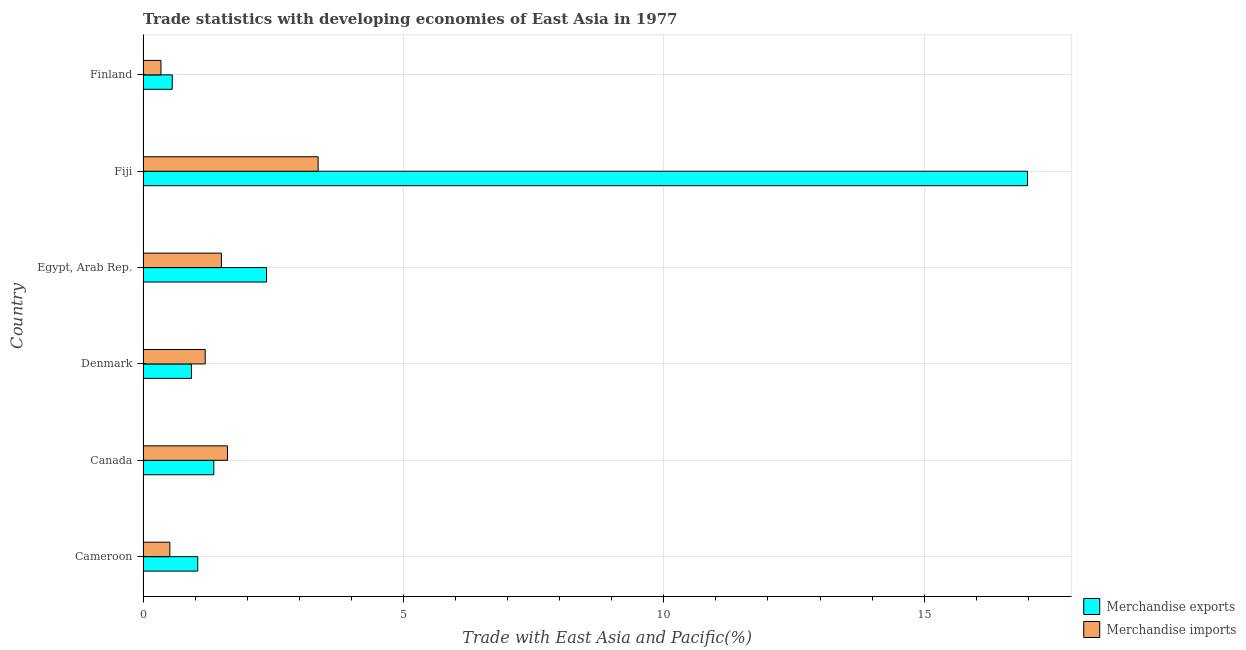Are the number of bars on each tick of the Y-axis equal?
Offer a very short reply. Yes. How many bars are there on the 6th tick from the top?
Your answer should be very brief. 2. How many bars are there on the 5th tick from the bottom?
Give a very brief answer. 2. What is the label of the 6th group of bars from the top?
Your answer should be compact. Cameroon. What is the merchandise imports in Finland?
Offer a terse response. 0.34. Across all countries, what is the maximum merchandise exports?
Your answer should be compact. 16.98. Across all countries, what is the minimum merchandise imports?
Offer a terse response. 0.34. In which country was the merchandise exports maximum?
Your response must be concise. Fiji. In which country was the merchandise imports minimum?
Provide a short and direct response. Finland. What is the total merchandise exports in the graph?
Give a very brief answer. 23.25. What is the difference between the merchandise exports in Canada and that in Denmark?
Your answer should be very brief. 0.43. What is the difference between the merchandise imports in Finland and the merchandise exports in Egypt, Arab Rep.?
Keep it short and to the point. -2.03. What is the average merchandise imports per country?
Give a very brief answer. 1.42. What is the difference between the merchandise exports and merchandise imports in Canada?
Make the answer very short. -0.26. In how many countries, is the merchandise imports greater than 15 %?
Offer a terse response. 0. What is the ratio of the merchandise imports in Canada to that in Denmark?
Your answer should be very brief. 1.36. Is the merchandise imports in Denmark less than that in Egypt, Arab Rep.?
Make the answer very short. Yes. Is the difference between the merchandise exports in Cameroon and Denmark greater than the difference between the merchandise imports in Cameroon and Denmark?
Provide a succinct answer. Yes. What is the difference between the highest and the second highest merchandise imports?
Your answer should be very brief. 1.74. What is the difference between the highest and the lowest merchandise exports?
Make the answer very short. 16.42. What does the 1st bar from the bottom in Fiji represents?
Provide a short and direct response. Merchandise exports. Are all the bars in the graph horizontal?
Your response must be concise. Yes. How many countries are there in the graph?
Your answer should be compact. 6. Are the values on the major ticks of X-axis written in scientific E-notation?
Ensure brevity in your answer.  No. Does the graph contain any zero values?
Your answer should be very brief. No. Does the graph contain grids?
Provide a short and direct response. Yes. Where does the legend appear in the graph?
Your response must be concise. Bottom right. How are the legend labels stacked?
Offer a terse response. Vertical. What is the title of the graph?
Give a very brief answer. Trade statistics with developing economies of East Asia in 1977. Does "Under five" appear as one of the legend labels in the graph?
Provide a succinct answer. No. What is the label or title of the X-axis?
Provide a short and direct response. Trade with East Asia and Pacific(%). What is the label or title of the Y-axis?
Offer a terse response. Country. What is the Trade with East Asia and Pacific(%) of Merchandise exports in Cameroon?
Keep it short and to the point. 1.05. What is the Trade with East Asia and Pacific(%) of Merchandise imports in Cameroon?
Your answer should be compact. 0.51. What is the Trade with East Asia and Pacific(%) in Merchandise exports in Canada?
Provide a succinct answer. 1.36. What is the Trade with East Asia and Pacific(%) in Merchandise imports in Canada?
Provide a short and direct response. 1.62. What is the Trade with East Asia and Pacific(%) in Merchandise exports in Denmark?
Your answer should be compact. 0.93. What is the Trade with East Asia and Pacific(%) of Merchandise imports in Denmark?
Offer a very short reply. 1.19. What is the Trade with East Asia and Pacific(%) of Merchandise exports in Egypt, Arab Rep.?
Your answer should be compact. 2.37. What is the Trade with East Asia and Pacific(%) in Merchandise imports in Egypt, Arab Rep.?
Provide a succinct answer. 1.51. What is the Trade with East Asia and Pacific(%) in Merchandise exports in Fiji?
Make the answer very short. 16.98. What is the Trade with East Asia and Pacific(%) in Merchandise imports in Fiji?
Make the answer very short. 3.36. What is the Trade with East Asia and Pacific(%) of Merchandise exports in Finland?
Offer a very short reply. 0.56. What is the Trade with East Asia and Pacific(%) in Merchandise imports in Finland?
Provide a short and direct response. 0.34. Across all countries, what is the maximum Trade with East Asia and Pacific(%) of Merchandise exports?
Provide a short and direct response. 16.98. Across all countries, what is the maximum Trade with East Asia and Pacific(%) of Merchandise imports?
Your answer should be compact. 3.36. Across all countries, what is the minimum Trade with East Asia and Pacific(%) in Merchandise exports?
Give a very brief answer. 0.56. Across all countries, what is the minimum Trade with East Asia and Pacific(%) of Merchandise imports?
Your response must be concise. 0.34. What is the total Trade with East Asia and Pacific(%) of Merchandise exports in the graph?
Give a very brief answer. 23.25. What is the total Trade with East Asia and Pacific(%) in Merchandise imports in the graph?
Your answer should be compact. 8.54. What is the difference between the Trade with East Asia and Pacific(%) of Merchandise exports in Cameroon and that in Canada?
Keep it short and to the point. -0.31. What is the difference between the Trade with East Asia and Pacific(%) of Merchandise imports in Cameroon and that in Canada?
Keep it short and to the point. -1.11. What is the difference between the Trade with East Asia and Pacific(%) in Merchandise exports in Cameroon and that in Denmark?
Provide a succinct answer. 0.12. What is the difference between the Trade with East Asia and Pacific(%) of Merchandise imports in Cameroon and that in Denmark?
Ensure brevity in your answer.  -0.68. What is the difference between the Trade with East Asia and Pacific(%) of Merchandise exports in Cameroon and that in Egypt, Arab Rep.?
Make the answer very short. -1.32. What is the difference between the Trade with East Asia and Pacific(%) in Merchandise imports in Cameroon and that in Egypt, Arab Rep.?
Your answer should be compact. -0.99. What is the difference between the Trade with East Asia and Pacific(%) in Merchandise exports in Cameroon and that in Fiji?
Provide a succinct answer. -15.94. What is the difference between the Trade with East Asia and Pacific(%) in Merchandise imports in Cameroon and that in Fiji?
Provide a succinct answer. -2.85. What is the difference between the Trade with East Asia and Pacific(%) of Merchandise exports in Cameroon and that in Finland?
Ensure brevity in your answer.  0.49. What is the difference between the Trade with East Asia and Pacific(%) in Merchandise imports in Cameroon and that in Finland?
Make the answer very short. 0.17. What is the difference between the Trade with East Asia and Pacific(%) of Merchandise exports in Canada and that in Denmark?
Keep it short and to the point. 0.43. What is the difference between the Trade with East Asia and Pacific(%) in Merchandise imports in Canada and that in Denmark?
Give a very brief answer. 0.43. What is the difference between the Trade with East Asia and Pacific(%) in Merchandise exports in Canada and that in Egypt, Arab Rep.?
Give a very brief answer. -1.01. What is the difference between the Trade with East Asia and Pacific(%) in Merchandise imports in Canada and that in Egypt, Arab Rep.?
Your response must be concise. 0.12. What is the difference between the Trade with East Asia and Pacific(%) in Merchandise exports in Canada and that in Fiji?
Your answer should be compact. -15.63. What is the difference between the Trade with East Asia and Pacific(%) in Merchandise imports in Canada and that in Fiji?
Your answer should be very brief. -1.74. What is the difference between the Trade with East Asia and Pacific(%) of Merchandise exports in Canada and that in Finland?
Provide a succinct answer. 0.8. What is the difference between the Trade with East Asia and Pacific(%) of Merchandise imports in Canada and that in Finland?
Ensure brevity in your answer.  1.28. What is the difference between the Trade with East Asia and Pacific(%) in Merchandise exports in Denmark and that in Egypt, Arab Rep.?
Give a very brief answer. -1.44. What is the difference between the Trade with East Asia and Pacific(%) of Merchandise imports in Denmark and that in Egypt, Arab Rep.?
Provide a succinct answer. -0.31. What is the difference between the Trade with East Asia and Pacific(%) in Merchandise exports in Denmark and that in Fiji?
Offer a terse response. -16.06. What is the difference between the Trade with East Asia and Pacific(%) in Merchandise imports in Denmark and that in Fiji?
Offer a terse response. -2.17. What is the difference between the Trade with East Asia and Pacific(%) of Merchandise exports in Denmark and that in Finland?
Make the answer very short. 0.37. What is the difference between the Trade with East Asia and Pacific(%) in Merchandise imports in Denmark and that in Finland?
Your response must be concise. 0.85. What is the difference between the Trade with East Asia and Pacific(%) of Merchandise exports in Egypt, Arab Rep. and that in Fiji?
Keep it short and to the point. -14.61. What is the difference between the Trade with East Asia and Pacific(%) in Merchandise imports in Egypt, Arab Rep. and that in Fiji?
Provide a succinct answer. -1.86. What is the difference between the Trade with East Asia and Pacific(%) of Merchandise exports in Egypt, Arab Rep. and that in Finland?
Provide a short and direct response. 1.81. What is the difference between the Trade with East Asia and Pacific(%) of Merchandise imports in Egypt, Arab Rep. and that in Finland?
Offer a very short reply. 1.16. What is the difference between the Trade with East Asia and Pacific(%) in Merchandise exports in Fiji and that in Finland?
Your answer should be very brief. 16.42. What is the difference between the Trade with East Asia and Pacific(%) in Merchandise imports in Fiji and that in Finland?
Your response must be concise. 3.02. What is the difference between the Trade with East Asia and Pacific(%) in Merchandise exports in Cameroon and the Trade with East Asia and Pacific(%) in Merchandise imports in Canada?
Your answer should be compact. -0.57. What is the difference between the Trade with East Asia and Pacific(%) of Merchandise exports in Cameroon and the Trade with East Asia and Pacific(%) of Merchandise imports in Denmark?
Your response must be concise. -0.14. What is the difference between the Trade with East Asia and Pacific(%) of Merchandise exports in Cameroon and the Trade with East Asia and Pacific(%) of Merchandise imports in Egypt, Arab Rep.?
Offer a very short reply. -0.46. What is the difference between the Trade with East Asia and Pacific(%) of Merchandise exports in Cameroon and the Trade with East Asia and Pacific(%) of Merchandise imports in Fiji?
Make the answer very short. -2.31. What is the difference between the Trade with East Asia and Pacific(%) of Merchandise exports in Cameroon and the Trade with East Asia and Pacific(%) of Merchandise imports in Finland?
Keep it short and to the point. 0.71. What is the difference between the Trade with East Asia and Pacific(%) in Merchandise exports in Canada and the Trade with East Asia and Pacific(%) in Merchandise imports in Denmark?
Keep it short and to the point. 0.16. What is the difference between the Trade with East Asia and Pacific(%) of Merchandise exports in Canada and the Trade with East Asia and Pacific(%) of Merchandise imports in Egypt, Arab Rep.?
Provide a short and direct response. -0.15. What is the difference between the Trade with East Asia and Pacific(%) in Merchandise exports in Canada and the Trade with East Asia and Pacific(%) in Merchandise imports in Fiji?
Your answer should be very brief. -2. What is the difference between the Trade with East Asia and Pacific(%) in Merchandise exports in Canada and the Trade with East Asia and Pacific(%) in Merchandise imports in Finland?
Provide a succinct answer. 1.01. What is the difference between the Trade with East Asia and Pacific(%) of Merchandise exports in Denmark and the Trade with East Asia and Pacific(%) of Merchandise imports in Egypt, Arab Rep.?
Your response must be concise. -0.58. What is the difference between the Trade with East Asia and Pacific(%) of Merchandise exports in Denmark and the Trade with East Asia and Pacific(%) of Merchandise imports in Fiji?
Make the answer very short. -2.43. What is the difference between the Trade with East Asia and Pacific(%) of Merchandise exports in Denmark and the Trade with East Asia and Pacific(%) of Merchandise imports in Finland?
Make the answer very short. 0.59. What is the difference between the Trade with East Asia and Pacific(%) in Merchandise exports in Egypt, Arab Rep. and the Trade with East Asia and Pacific(%) in Merchandise imports in Fiji?
Offer a very short reply. -0.99. What is the difference between the Trade with East Asia and Pacific(%) in Merchandise exports in Egypt, Arab Rep. and the Trade with East Asia and Pacific(%) in Merchandise imports in Finland?
Your answer should be compact. 2.03. What is the difference between the Trade with East Asia and Pacific(%) in Merchandise exports in Fiji and the Trade with East Asia and Pacific(%) in Merchandise imports in Finland?
Give a very brief answer. 16.64. What is the average Trade with East Asia and Pacific(%) of Merchandise exports per country?
Your answer should be very brief. 3.88. What is the average Trade with East Asia and Pacific(%) of Merchandise imports per country?
Ensure brevity in your answer.  1.42. What is the difference between the Trade with East Asia and Pacific(%) of Merchandise exports and Trade with East Asia and Pacific(%) of Merchandise imports in Cameroon?
Your response must be concise. 0.54. What is the difference between the Trade with East Asia and Pacific(%) of Merchandise exports and Trade with East Asia and Pacific(%) of Merchandise imports in Canada?
Ensure brevity in your answer.  -0.26. What is the difference between the Trade with East Asia and Pacific(%) of Merchandise exports and Trade with East Asia and Pacific(%) of Merchandise imports in Denmark?
Offer a very short reply. -0.26. What is the difference between the Trade with East Asia and Pacific(%) of Merchandise exports and Trade with East Asia and Pacific(%) of Merchandise imports in Egypt, Arab Rep.?
Your answer should be very brief. 0.87. What is the difference between the Trade with East Asia and Pacific(%) in Merchandise exports and Trade with East Asia and Pacific(%) in Merchandise imports in Fiji?
Your answer should be compact. 13.62. What is the difference between the Trade with East Asia and Pacific(%) in Merchandise exports and Trade with East Asia and Pacific(%) in Merchandise imports in Finland?
Offer a very short reply. 0.22. What is the ratio of the Trade with East Asia and Pacific(%) of Merchandise exports in Cameroon to that in Canada?
Give a very brief answer. 0.77. What is the ratio of the Trade with East Asia and Pacific(%) of Merchandise imports in Cameroon to that in Canada?
Provide a succinct answer. 0.32. What is the ratio of the Trade with East Asia and Pacific(%) of Merchandise exports in Cameroon to that in Denmark?
Ensure brevity in your answer.  1.13. What is the ratio of the Trade with East Asia and Pacific(%) in Merchandise imports in Cameroon to that in Denmark?
Ensure brevity in your answer.  0.43. What is the ratio of the Trade with East Asia and Pacific(%) of Merchandise exports in Cameroon to that in Egypt, Arab Rep.?
Keep it short and to the point. 0.44. What is the ratio of the Trade with East Asia and Pacific(%) in Merchandise imports in Cameroon to that in Egypt, Arab Rep.?
Offer a very short reply. 0.34. What is the ratio of the Trade with East Asia and Pacific(%) of Merchandise exports in Cameroon to that in Fiji?
Offer a terse response. 0.06. What is the ratio of the Trade with East Asia and Pacific(%) of Merchandise imports in Cameroon to that in Fiji?
Provide a succinct answer. 0.15. What is the ratio of the Trade with East Asia and Pacific(%) in Merchandise exports in Cameroon to that in Finland?
Your answer should be compact. 1.87. What is the ratio of the Trade with East Asia and Pacific(%) of Merchandise imports in Cameroon to that in Finland?
Keep it short and to the point. 1.5. What is the ratio of the Trade with East Asia and Pacific(%) in Merchandise exports in Canada to that in Denmark?
Provide a succinct answer. 1.46. What is the ratio of the Trade with East Asia and Pacific(%) in Merchandise imports in Canada to that in Denmark?
Offer a very short reply. 1.36. What is the ratio of the Trade with East Asia and Pacific(%) in Merchandise exports in Canada to that in Egypt, Arab Rep.?
Offer a terse response. 0.57. What is the ratio of the Trade with East Asia and Pacific(%) of Merchandise imports in Canada to that in Egypt, Arab Rep.?
Provide a short and direct response. 1.08. What is the ratio of the Trade with East Asia and Pacific(%) in Merchandise exports in Canada to that in Fiji?
Provide a short and direct response. 0.08. What is the ratio of the Trade with East Asia and Pacific(%) in Merchandise imports in Canada to that in Fiji?
Your answer should be very brief. 0.48. What is the ratio of the Trade with East Asia and Pacific(%) in Merchandise exports in Canada to that in Finland?
Your answer should be very brief. 2.42. What is the ratio of the Trade with East Asia and Pacific(%) in Merchandise imports in Canada to that in Finland?
Your response must be concise. 4.72. What is the ratio of the Trade with East Asia and Pacific(%) in Merchandise exports in Denmark to that in Egypt, Arab Rep.?
Provide a short and direct response. 0.39. What is the ratio of the Trade with East Asia and Pacific(%) of Merchandise imports in Denmark to that in Egypt, Arab Rep.?
Ensure brevity in your answer.  0.79. What is the ratio of the Trade with East Asia and Pacific(%) in Merchandise exports in Denmark to that in Fiji?
Provide a succinct answer. 0.05. What is the ratio of the Trade with East Asia and Pacific(%) in Merchandise imports in Denmark to that in Fiji?
Your response must be concise. 0.35. What is the ratio of the Trade with East Asia and Pacific(%) in Merchandise exports in Denmark to that in Finland?
Give a very brief answer. 1.66. What is the ratio of the Trade with East Asia and Pacific(%) of Merchandise imports in Denmark to that in Finland?
Keep it short and to the point. 3.47. What is the ratio of the Trade with East Asia and Pacific(%) of Merchandise exports in Egypt, Arab Rep. to that in Fiji?
Keep it short and to the point. 0.14. What is the ratio of the Trade with East Asia and Pacific(%) of Merchandise imports in Egypt, Arab Rep. to that in Fiji?
Offer a terse response. 0.45. What is the ratio of the Trade with East Asia and Pacific(%) in Merchandise exports in Egypt, Arab Rep. to that in Finland?
Provide a succinct answer. 4.23. What is the ratio of the Trade with East Asia and Pacific(%) of Merchandise imports in Egypt, Arab Rep. to that in Finland?
Your response must be concise. 4.38. What is the ratio of the Trade with East Asia and Pacific(%) of Merchandise exports in Fiji to that in Finland?
Your answer should be very brief. 30.32. What is the ratio of the Trade with East Asia and Pacific(%) of Merchandise imports in Fiji to that in Finland?
Offer a very short reply. 9.78. What is the difference between the highest and the second highest Trade with East Asia and Pacific(%) of Merchandise exports?
Give a very brief answer. 14.61. What is the difference between the highest and the second highest Trade with East Asia and Pacific(%) in Merchandise imports?
Give a very brief answer. 1.74. What is the difference between the highest and the lowest Trade with East Asia and Pacific(%) of Merchandise exports?
Offer a very short reply. 16.42. What is the difference between the highest and the lowest Trade with East Asia and Pacific(%) of Merchandise imports?
Provide a short and direct response. 3.02. 